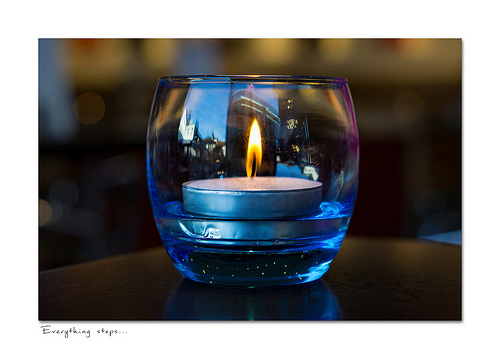<image>
Is there a candle on the table? Yes. Looking at the image, I can see the candle is positioned on top of the table, with the table providing support. Where is the can in relation to the ja? Is it in the ja? Yes. The can is contained within or inside the ja, showing a containment relationship. Is there a candle above the glass? No. The candle is not positioned above the glass. The vertical arrangement shows a different relationship. 